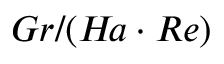Convert formula to latex. <formula><loc_0><loc_0><loc_500><loc_500>G r / ( H \, a \cdot R e )</formula> 